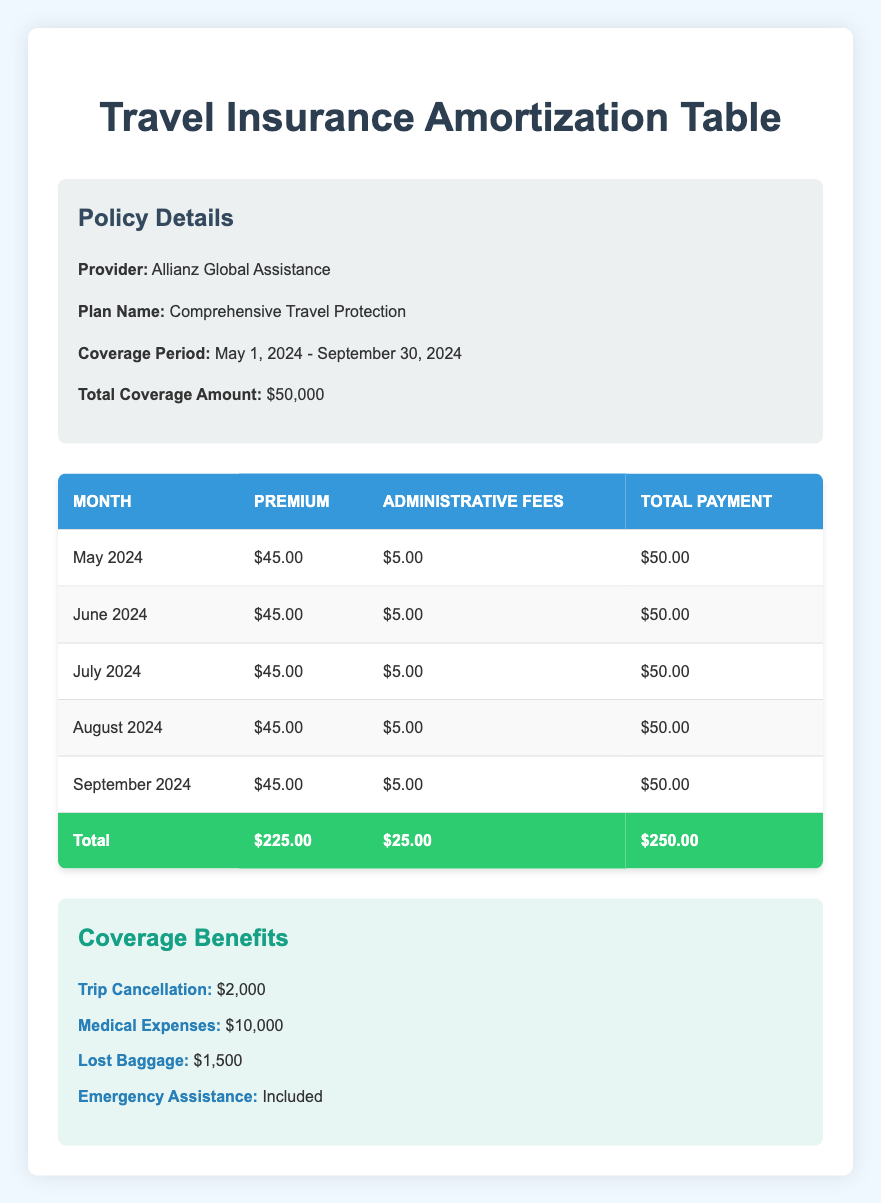What is the total premium paid over the coverage period? The coverage period is from May to September 2024, which is five months. Each month has a premium of $45.00. Therefore, the total premium is calculated as 5 months * $45.00 = $225.00.
Answer: $225.00 What is the total amount paid including administrative fees? Each month there is an administrative fee of $5.00 for five months, which totals to 5 months * $5.00 = $25.00. Adding this to the total premium of $225.00 results in a total payment of $250.00.
Answer: $250.00 Is emergency assistance included in the coverage benefits? The table states "Emergency Assistance: Included" which confirms that emergency assistance is part of the coverage benefits.
Answer: Yes What is the total amount paid in administrative fees over the entire coverage period? Since the administrative fee is $5.00 each month over five months, the total for administrative fees is 5 months * $5.00 = $25.00.
Answer: $25.00 How much coverage is provided for medical expenses? The coverage benefits listed state that the amount provided for medical expenses is $10,000.
Answer: $10,000 What is the total premium and administrative fee paid each month? Each month has a premium of $45.00 and an administrative fee of $5.00. To find the total payment each month, you add these two amounts: $45.00 + $5.00 = $50.00.
Answer: $50.00 In total, how much is covered for trip cancellation? According to the coverage benefits, the amount for trip cancellation is $2,000.
Answer: $2,000 If someone were to calculate the average monthly payment, what would that be? The total payment for the entire period is $250.00 for five months. The average monthly payment can be calculated as $250.00 / 5 months = $50.00 per month.
Answer: $50.00 Is the total payment for September higher than for May? The total payment for both months is the same at $50.00 each. Thus, the total payment for September is not higher than May.
Answer: No 